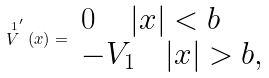Convert formula to latex. <formula><loc_0><loc_0><loc_500><loc_500>\stackrel { 1 } { V } ^ { \prime } ( x ) = \begin{array} { l } 0 \quad \, | x | < b \\ - V _ { 1 } \quad | x | > b , \end{array}</formula> 